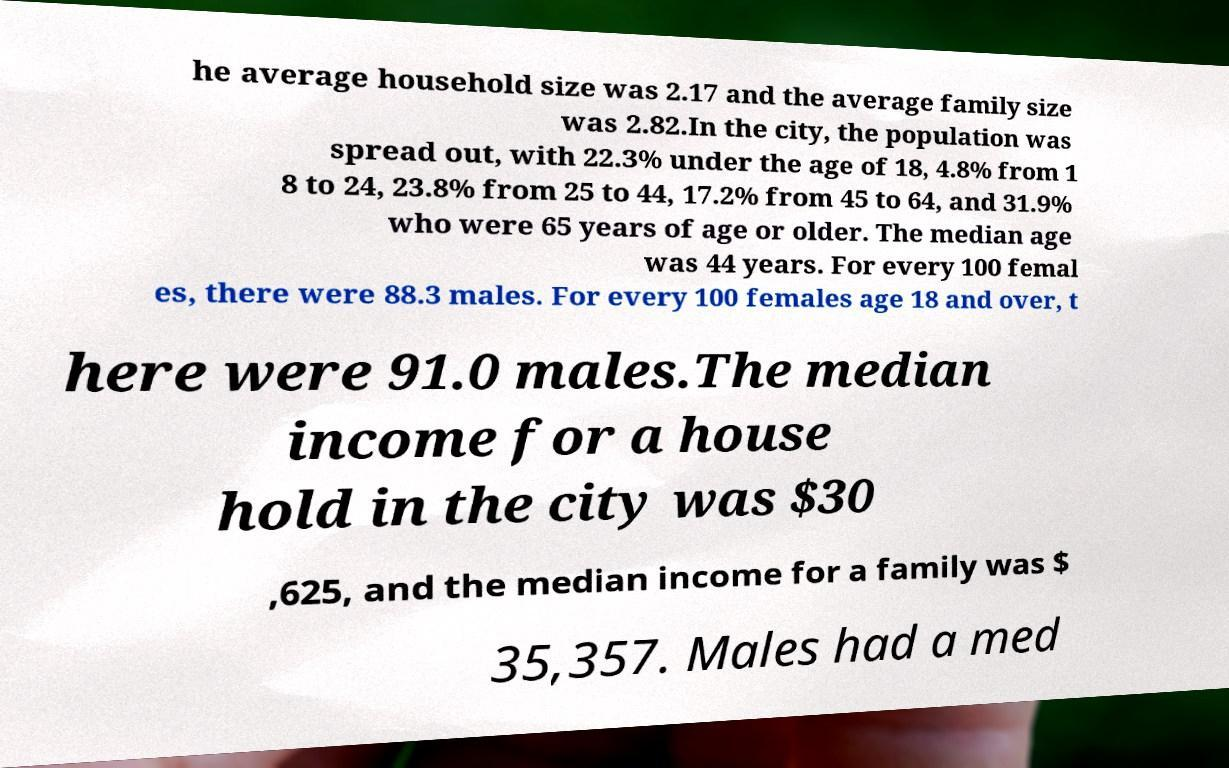There's text embedded in this image that I need extracted. Can you transcribe it verbatim? he average household size was 2.17 and the average family size was 2.82.In the city, the population was spread out, with 22.3% under the age of 18, 4.8% from 1 8 to 24, 23.8% from 25 to 44, 17.2% from 45 to 64, and 31.9% who were 65 years of age or older. The median age was 44 years. For every 100 femal es, there were 88.3 males. For every 100 females age 18 and over, t here were 91.0 males.The median income for a house hold in the city was $30 ,625, and the median income for a family was $ 35,357. Males had a med 